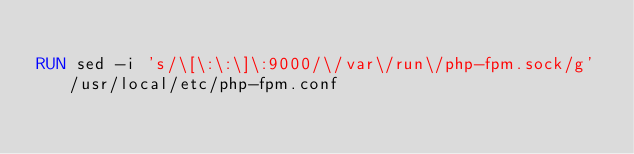<code> <loc_0><loc_0><loc_500><loc_500><_Dockerfile_>
RUN sed -i 's/\[\:\:\]\:9000/\/var\/run\/php-fpm.sock/g' /usr/local/etc/php-fpm.conf
</code> 